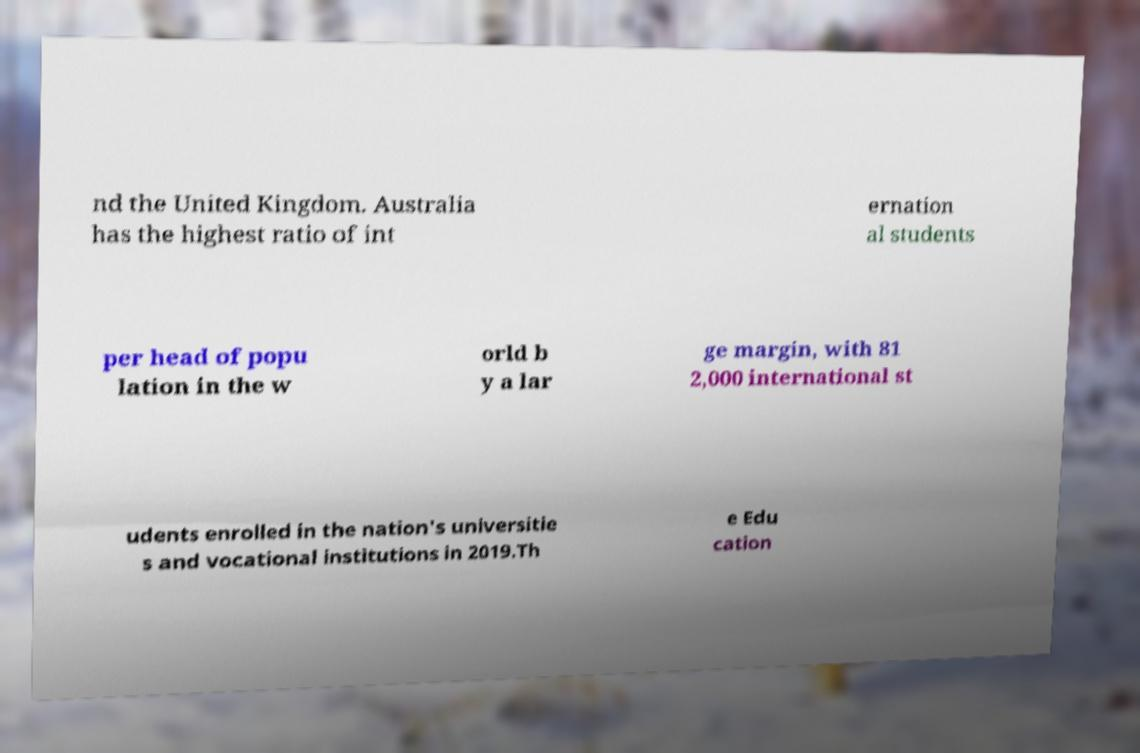Can you read and provide the text displayed in the image?This photo seems to have some interesting text. Can you extract and type it out for me? nd the United Kingdom. Australia has the highest ratio of int ernation al students per head of popu lation in the w orld b y a lar ge margin, with 81 2,000 international st udents enrolled in the nation's universitie s and vocational institutions in 2019.Th e Edu cation 